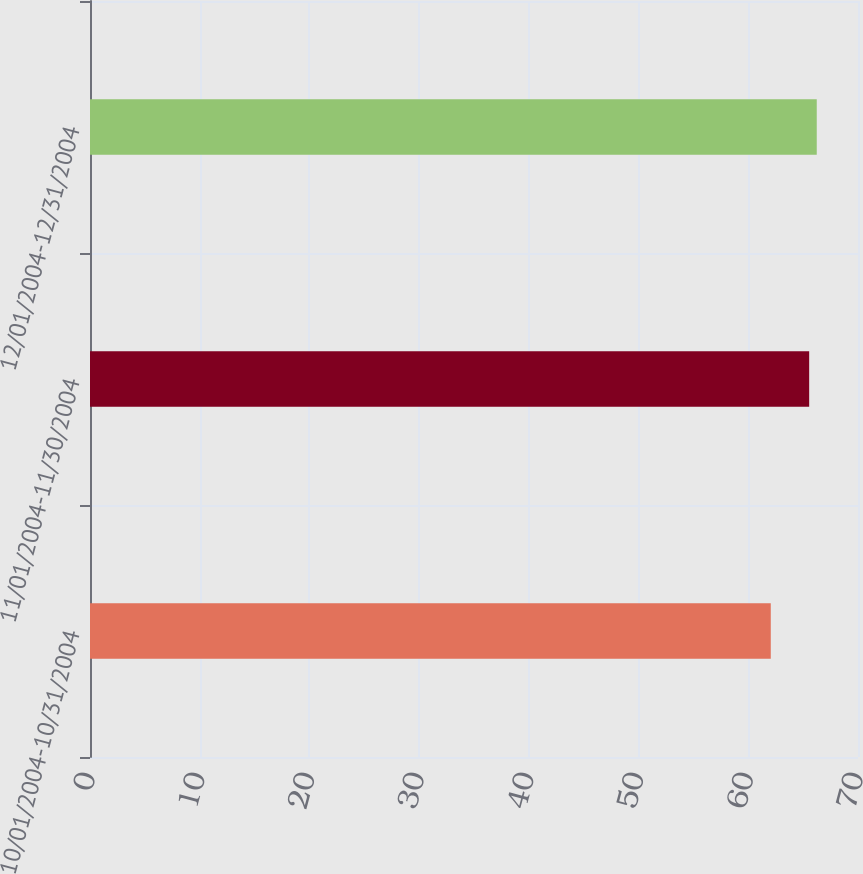Convert chart. <chart><loc_0><loc_0><loc_500><loc_500><bar_chart><fcel>10/01/2004-10/31/2004<fcel>11/01/2004-11/30/2004<fcel>12/01/2004-12/31/2004<nl><fcel>62.05<fcel>65.55<fcel>66.24<nl></chart> 